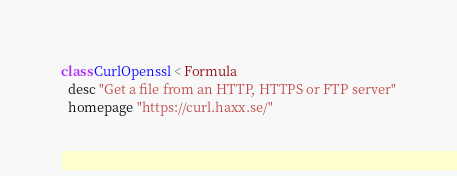Convert code to text. <code><loc_0><loc_0><loc_500><loc_500><_Ruby_>class CurlOpenssl < Formula
  desc "Get a file from an HTTP, HTTPS or FTP server"
  homepage "https://curl.haxx.se/"</code> 